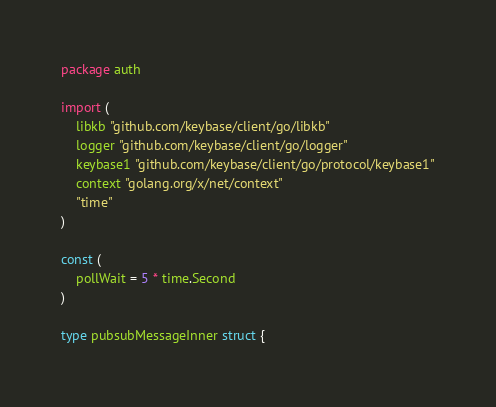<code> <loc_0><loc_0><loc_500><loc_500><_Go_>package auth

import (
	libkb "github.com/keybase/client/go/libkb"
	logger "github.com/keybase/client/go/logger"
	keybase1 "github.com/keybase/client/go/protocol/keybase1"
	context "golang.org/x/net/context"
	"time"
)

const (
	pollWait = 5 * time.Second
)

type pubsubMessageInner struct {</code> 